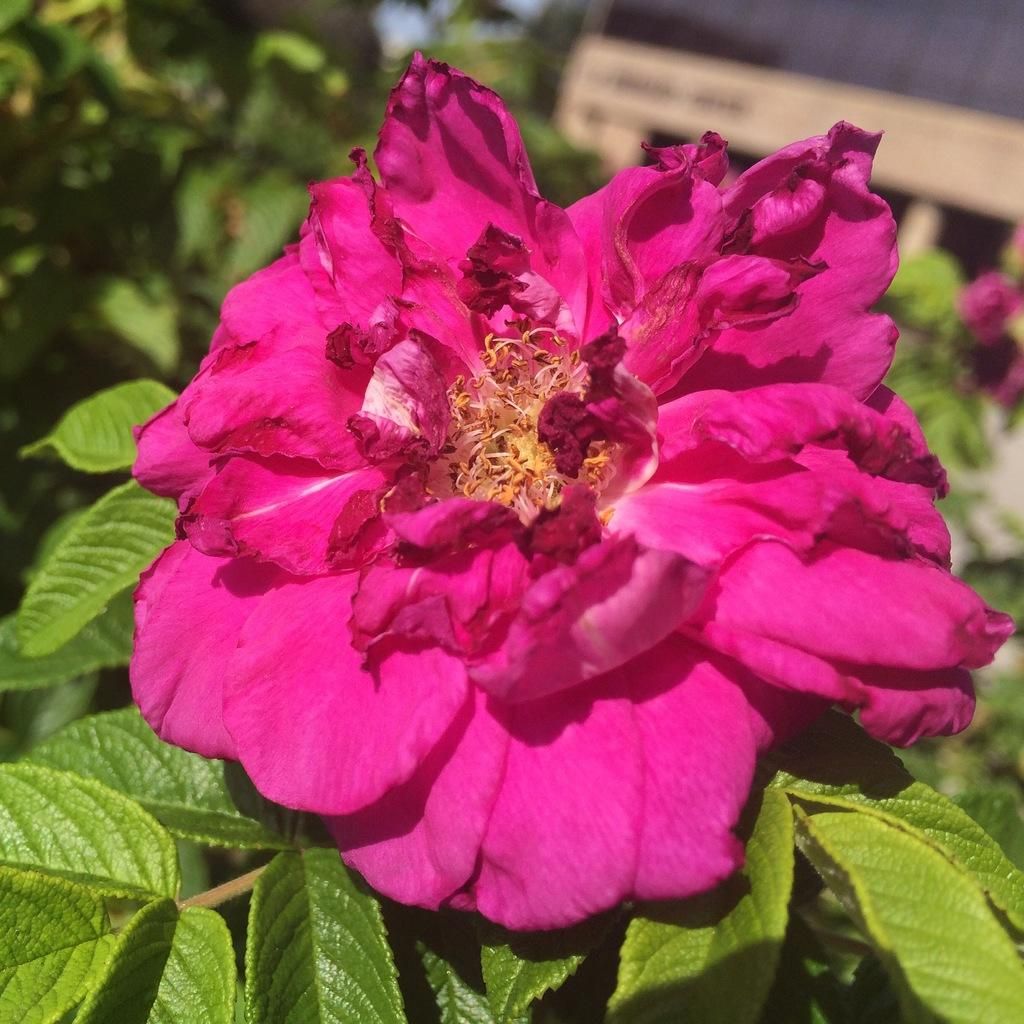What is the main subject of the image? There is a flower in the image. Can you describe the color of the flower? The flower is pink in color. Are there any other parts of the flower visible in the image? Yes, there are green leaves associated with the flower. Is there a glove placed next to the flower in the image? No, there is no glove present in the image. What type of afterthought is associated with the flower in the image? There is no afterthought associated with the flower in the image; it is a simple depiction of a pink flower with green leaves. 